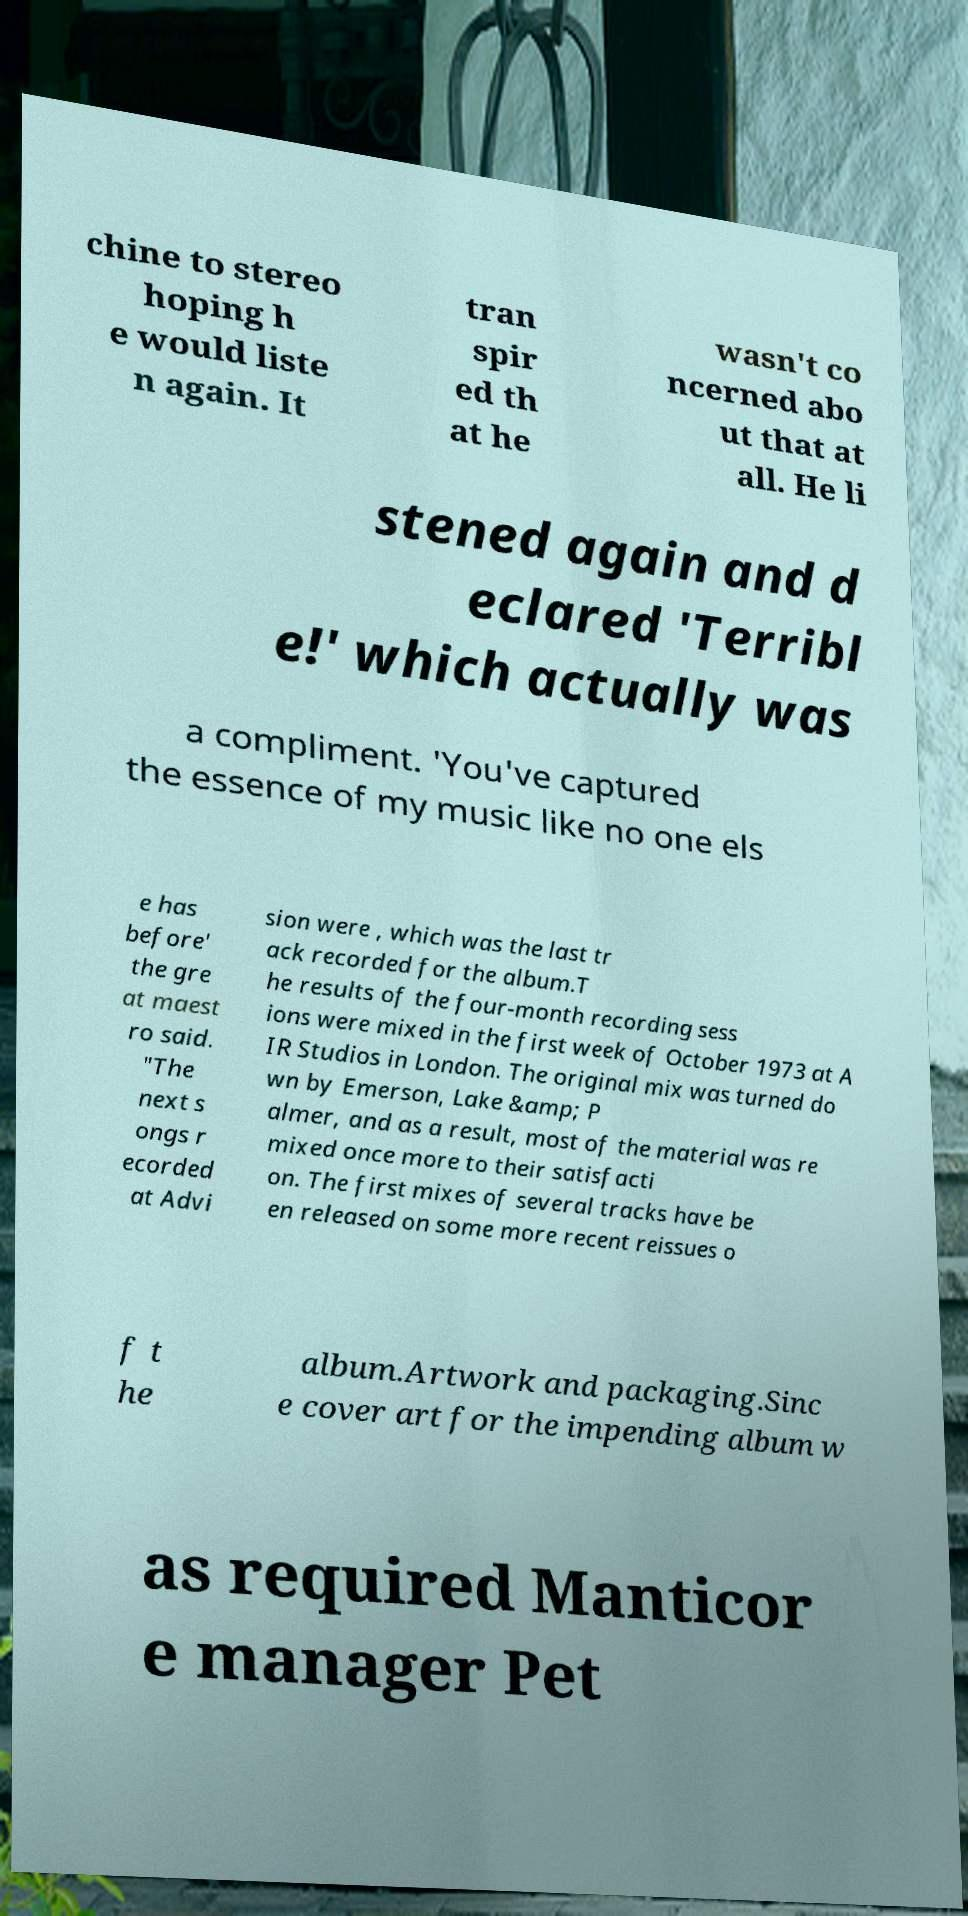Could you extract and type out the text from this image? chine to stereo hoping h e would liste n again. It tran spir ed th at he wasn't co ncerned abo ut that at all. He li stened again and d eclared 'Terribl e!' which actually was a compliment. 'You've captured the essence of my music like no one els e has before' the gre at maest ro said. "The next s ongs r ecorded at Advi sion were , which was the last tr ack recorded for the album.T he results of the four-month recording sess ions were mixed in the first week of October 1973 at A IR Studios in London. The original mix was turned do wn by Emerson, Lake &amp; P almer, and as a result, most of the material was re mixed once more to their satisfacti on. The first mixes of several tracks have be en released on some more recent reissues o f t he album.Artwork and packaging.Sinc e cover art for the impending album w as required Manticor e manager Pet 